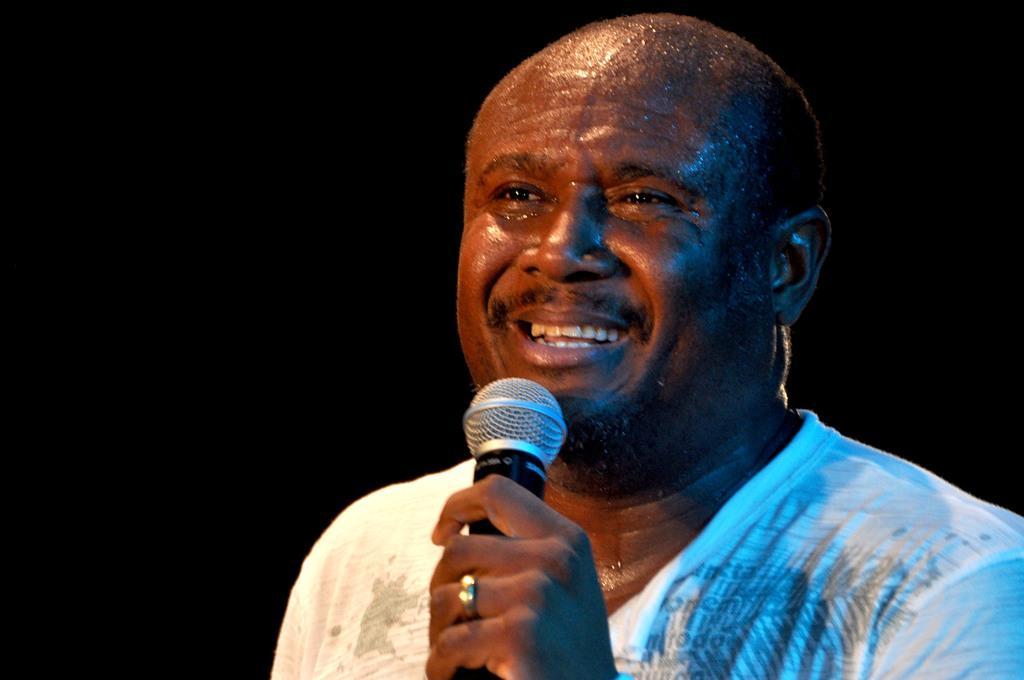Please provide a concise description of this image. In this image, we can see human is smiling, he hold microphone in his hand and he wear a ring on his finger. 